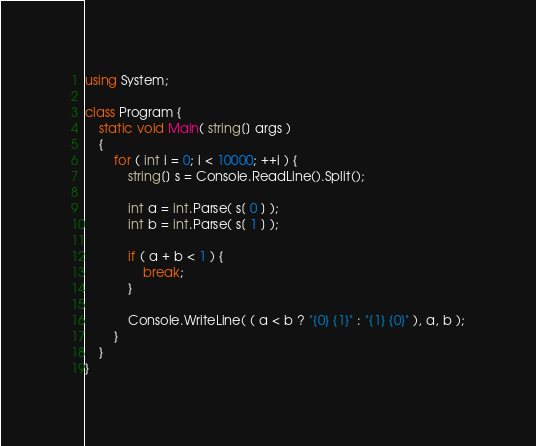<code> <loc_0><loc_0><loc_500><loc_500><_C#_>using System;

class Program {
    static void Main( string[] args )
    {
        for ( int i = 0; i < 10000; ++i ) {
            string[] s = Console.ReadLine().Split();

            int a = int.Parse( s[ 0 ] );
            int b = int.Parse( s[ 1 ] );

            if ( a + b < 1 ) {
                break;
            }

            Console.WriteLine( ( a < b ? "{0} {1}" : "{1} {0}" ), a, b );
        }
    }
}</code> 